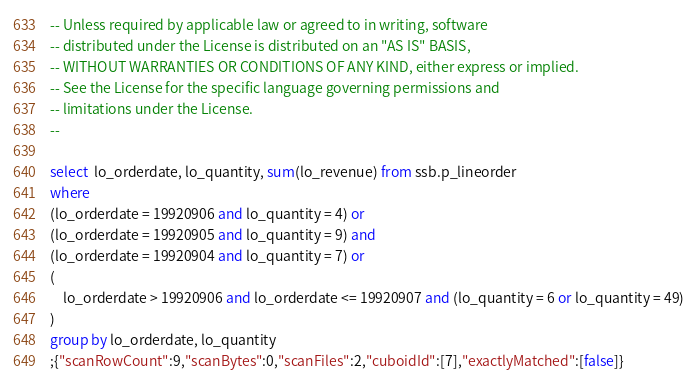Convert code to text. <code><loc_0><loc_0><loc_500><loc_500><_SQL_>-- Unless required by applicable law or agreed to in writing, software
-- distributed under the License is distributed on an "AS IS" BASIS,
-- WITHOUT WARRANTIES OR CONDITIONS OF ANY KIND, either express or implied.
-- See the License for the specific language governing permissions and
-- limitations under the License.
--

select  lo_orderdate, lo_quantity, sum(lo_revenue) from ssb.p_lineorder
where
(lo_orderdate = 19920906 and lo_quantity = 4) or
(lo_orderdate = 19920905 and lo_quantity = 9) and
(lo_orderdate = 19920904 and lo_quantity = 7) or
(
    lo_orderdate > 19920906 and lo_orderdate <= 19920907 and (lo_quantity = 6 or lo_quantity = 49)
)
group by lo_orderdate, lo_quantity
;{"scanRowCount":9,"scanBytes":0,"scanFiles":2,"cuboidId":[7],"exactlyMatched":[false]}</code> 